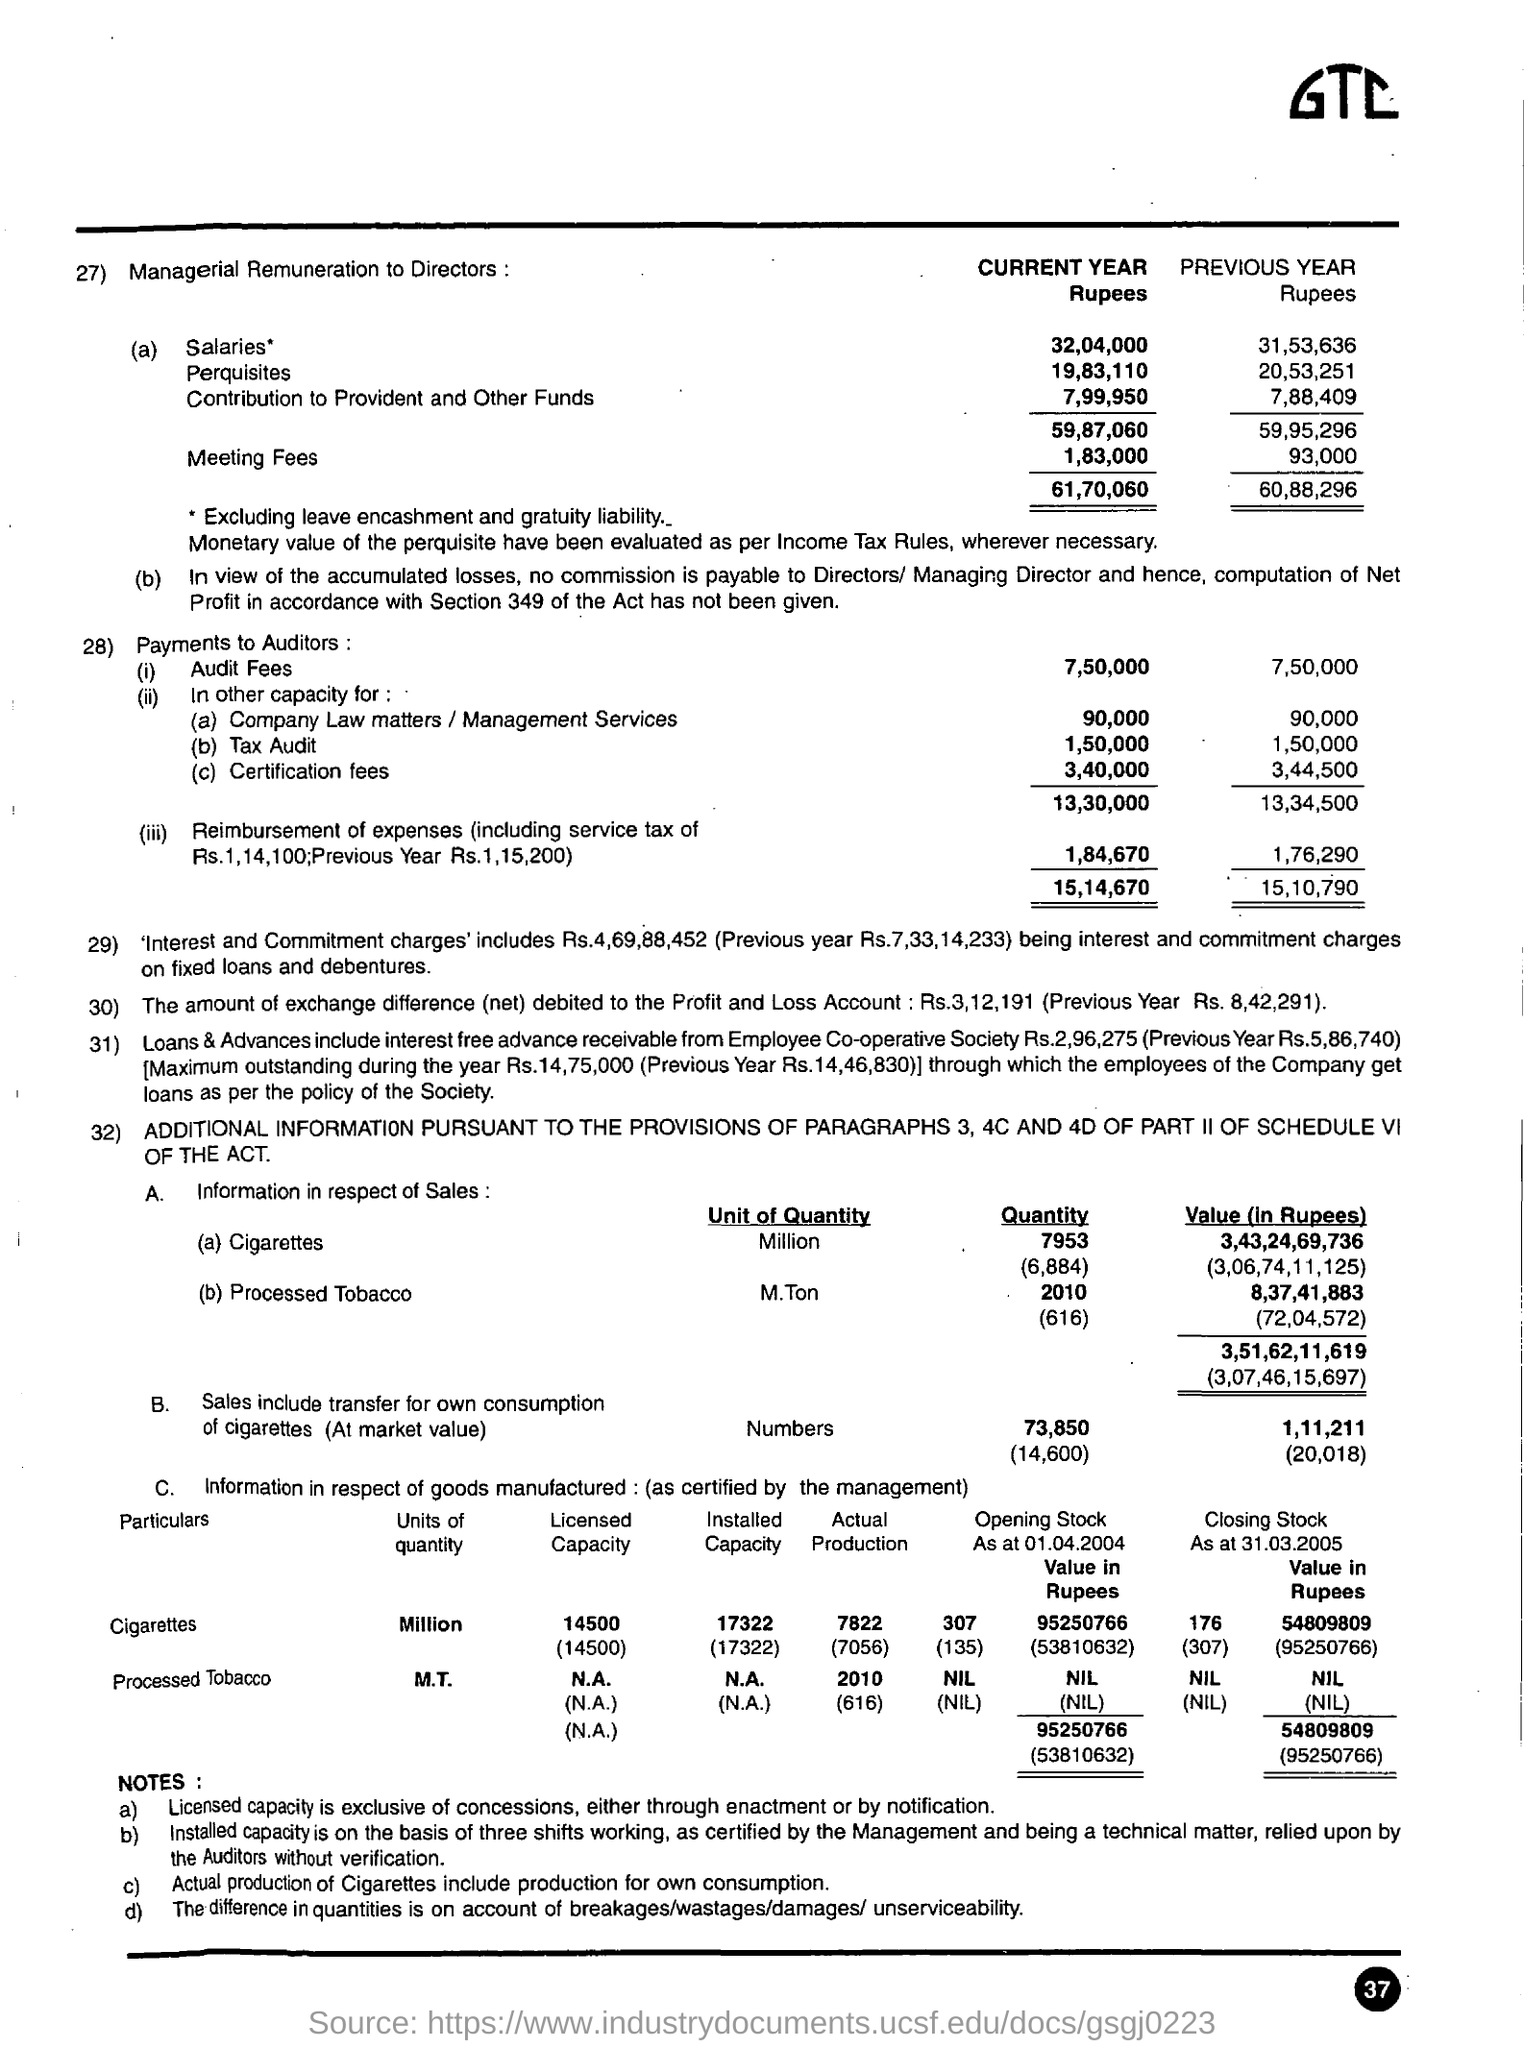How much amount was paid as 'Audit fees' in the current year in rupees?
Give a very brief answer. 7,50,000. How much amount was paid as 'Audit fees' in the previous year in rupees?
Your answer should be very brief. 7,50,000. How much is the salary for current year for managerial remuneration to directors?
Offer a very short reply. 32,04,000. How much amount was paid for the auditors as the certification fees in the current year?
Keep it short and to the point. 3,40,000. How much amount was paid for the auditors as the certification fees in the previous year?
Provide a short and direct response. 3,44,500. What is the licensed capacity of cigarettes in million?
Provide a succinct answer. 14500. In what unit,value of a cigarettes and processed tobacco is measured?
Your answer should be very brief. Rupees. How much amount of exchange difference (net) debited to the profit and loss account in the previous year?
Ensure brevity in your answer.  Rs. 8,42,291. 